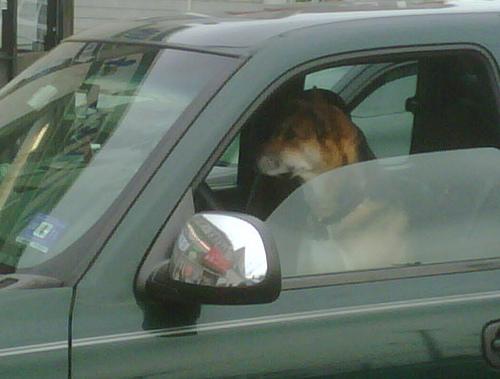What color is the vehicle?
Give a very brief answer. Green. Is the bear in the driver or passenger seat?
Write a very short answer. Driver. Is this dog driving this car?
Keep it brief. No. Can dogs drive a car?
Write a very short answer. No. What color is the car?
Keep it brief. Green. 